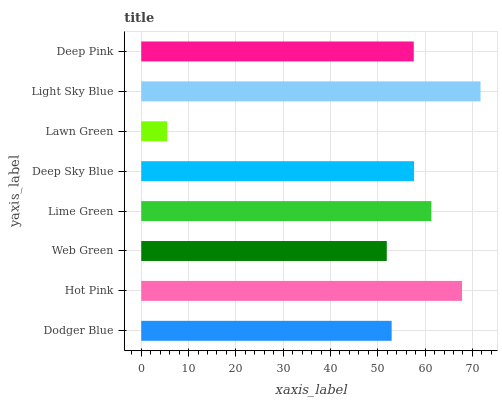Is Lawn Green the minimum?
Answer yes or no. Yes. Is Light Sky Blue the maximum?
Answer yes or no. Yes. Is Hot Pink the minimum?
Answer yes or no. No. Is Hot Pink the maximum?
Answer yes or no. No. Is Hot Pink greater than Dodger Blue?
Answer yes or no. Yes. Is Dodger Blue less than Hot Pink?
Answer yes or no. Yes. Is Dodger Blue greater than Hot Pink?
Answer yes or no. No. Is Hot Pink less than Dodger Blue?
Answer yes or no. No. Is Deep Sky Blue the high median?
Answer yes or no. Yes. Is Deep Pink the low median?
Answer yes or no. Yes. Is Lime Green the high median?
Answer yes or no. No. Is Dodger Blue the low median?
Answer yes or no. No. 